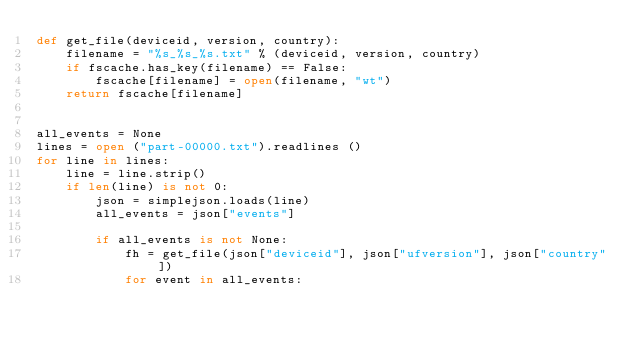<code> <loc_0><loc_0><loc_500><loc_500><_Python_>def get_file(deviceid, version, country):
    filename = "%s_%s_%s.txt" % (deviceid, version, country)
    if fscache.has_key(filename) == False:
        fscache[filename] = open(filename, "wt")
    return fscache[filename]


all_events = None
lines = open ("part-00000.txt").readlines ()
for line in lines:
    line = line.strip()
    if len(line) is not 0:
        json = simplejson.loads(line)
        all_events = json["events"]

        if all_events is not None:
            fh = get_file(json["deviceid"], json["ufversion"], json["country"])
            for event in all_events:</code> 